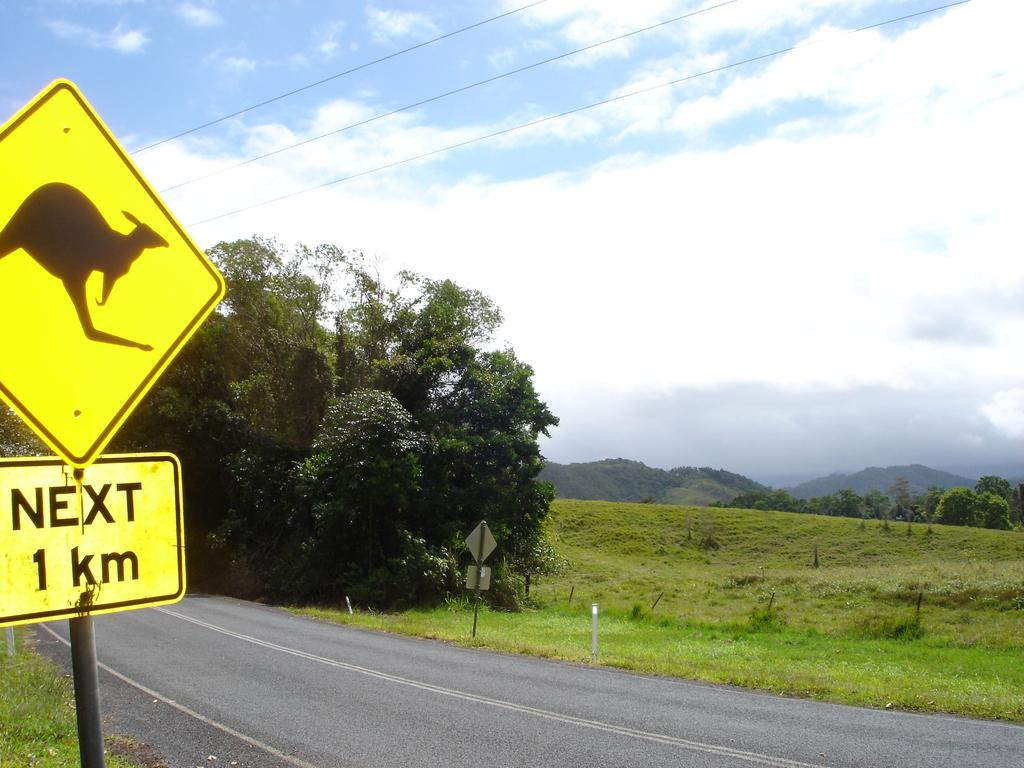<image>
Render a clear and concise summary of the photo. A sign with a kangaroo on it above a sign that says Next 1 km. 